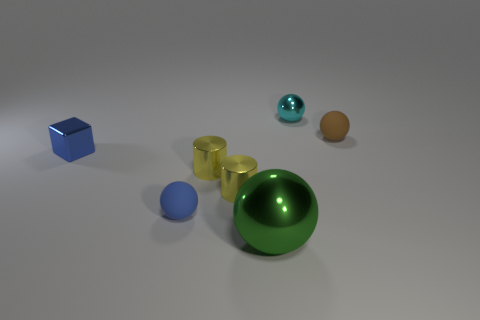Add 2 yellow cylinders. How many objects exist? 9 Subtract all small balls. How many balls are left? 1 Subtract all green balls. How many balls are left? 3 Subtract 3 balls. How many balls are left? 1 Add 2 balls. How many balls exist? 6 Subtract 0 green cubes. How many objects are left? 7 Subtract all balls. How many objects are left? 3 Subtract all red cubes. Subtract all red balls. How many cubes are left? 1 Subtract all red cylinders. How many brown balls are left? 1 Subtract all large purple blocks. Subtract all tiny blue metal things. How many objects are left? 6 